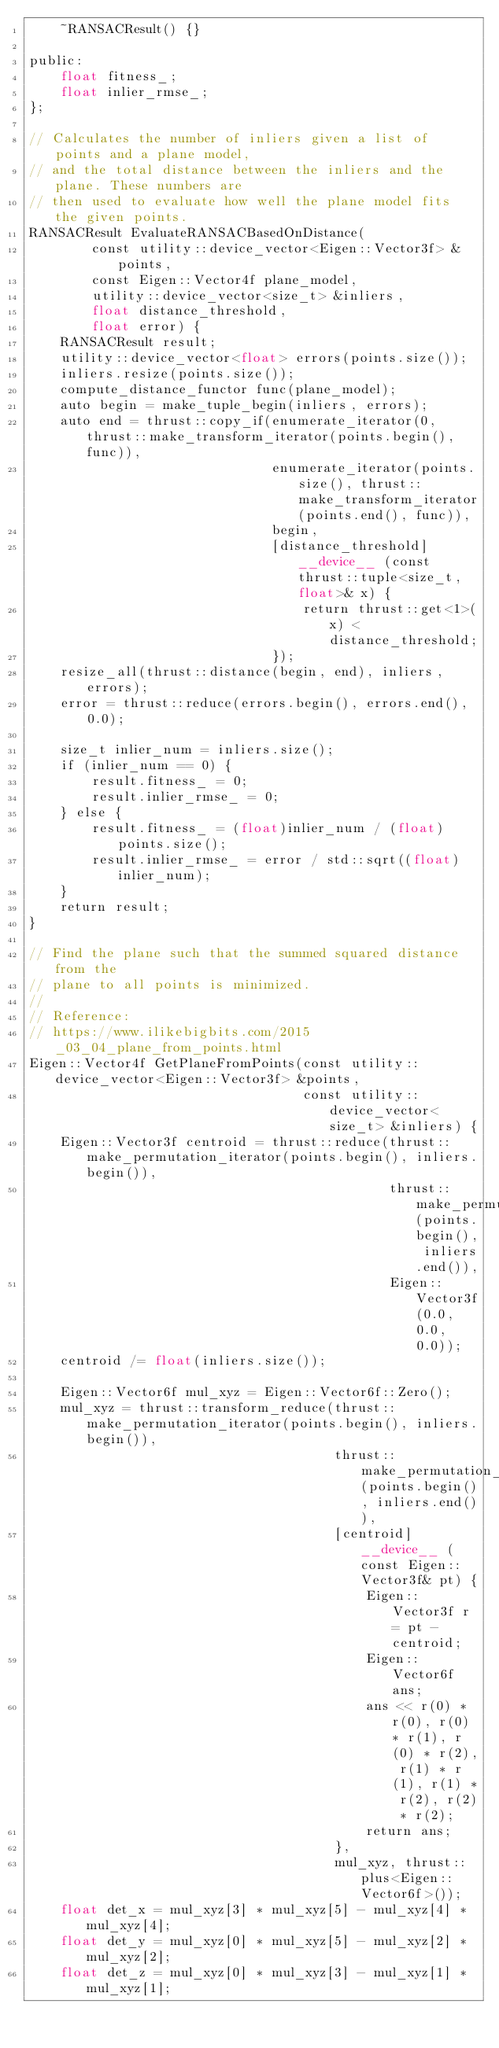Convert code to text. <code><loc_0><loc_0><loc_500><loc_500><_Cuda_>    ~RANSACResult() {}

public:
    float fitness_;
    float inlier_rmse_;
};

// Calculates the number of inliers given a list of points and a plane model,
// and the total distance between the inliers and the plane. These numbers are
// then used to evaluate how well the plane model fits the given points.
RANSACResult EvaluateRANSACBasedOnDistance(
        const utility::device_vector<Eigen::Vector3f> &points,
        const Eigen::Vector4f plane_model,
        utility::device_vector<size_t> &inliers,
        float distance_threshold,
        float error) {
    RANSACResult result;
    utility::device_vector<float> errors(points.size());
    inliers.resize(points.size());
    compute_distance_functor func(plane_model);
    auto begin = make_tuple_begin(inliers, errors);
    auto end = thrust::copy_if(enumerate_iterator(0, thrust::make_transform_iterator(points.begin(), func)),
                               enumerate_iterator(points.size(), thrust::make_transform_iterator(points.end(), func)),
                               begin,
                               [distance_threshold] __device__ (const thrust::tuple<size_t, float>& x) {
                                   return thrust::get<1>(x) < distance_threshold;
                               });
    resize_all(thrust::distance(begin, end), inliers, errors);
    error = thrust::reduce(errors.begin(), errors.end(), 0.0);

    size_t inlier_num = inliers.size();
    if (inlier_num == 0) {
        result.fitness_ = 0;
        result.inlier_rmse_ = 0;
    } else {
        result.fitness_ = (float)inlier_num / (float)points.size();
        result.inlier_rmse_ = error / std::sqrt((float)inlier_num);
    }
    return result;
}

// Find the plane such that the summed squared distance from the
// plane to all points is minimized.
//
// Reference:
// https://www.ilikebigbits.com/2015_03_04_plane_from_points.html
Eigen::Vector4f GetPlaneFromPoints(const utility::device_vector<Eigen::Vector3f> &points,
                                   const utility::device_vector<size_t> &inliers) {
    Eigen::Vector3f centroid = thrust::reduce(thrust::make_permutation_iterator(points.begin(), inliers.begin()),
                                              thrust::make_permutation_iterator(points.begin(), inliers.end()),
                                              Eigen::Vector3f(0.0, 0.0, 0.0));
    centroid /= float(inliers.size());

    Eigen::Vector6f mul_xyz = Eigen::Vector6f::Zero();
    mul_xyz = thrust::transform_reduce(thrust::make_permutation_iterator(points.begin(), inliers.begin()),
                                       thrust::make_permutation_iterator(points.begin(), inliers.end()),
                                       [centroid] __device__ (const Eigen::Vector3f& pt) {
                                           Eigen::Vector3f r = pt - centroid;
                                           Eigen::Vector6f ans;
                                           ans << r(0) * r(0), r(0) * r(1), r(0) * r(2), r(1) * r(1), r(1) * r(2), r(2) * r(2);
                                           return ans;
                                       },
                                       mul_xyz, thrust::plus<Eigen::Vector6f>());
    float det_x = mul_xyz[3] * mul_xyz[5] - mul_xyz[4] * mul_xyz[4];
    float det_y = mul_xyz[0] * mul_xyz[5] - mul_xyz[2] * mul_xyz[2];
    float det_z = mul_xyz[0] * mul_xyz[3] - mul_xyz[1] * mul_xyz[1];
</code> 